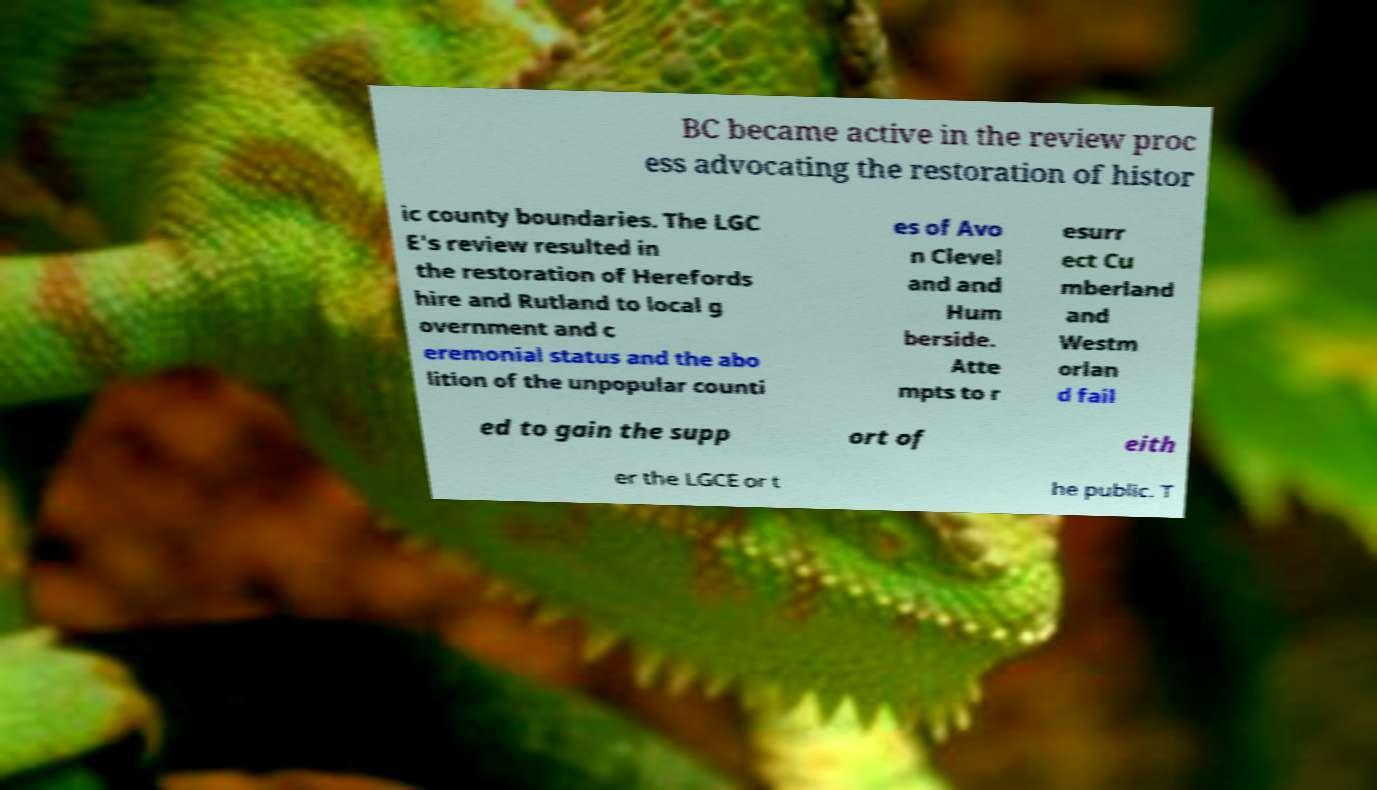Can you accurately transcribe the text from the provided image for me? BC became active in the review proc ess advocating the restoration of histor ic county boundaries. The LGC E's review resulted in the restoration of Herefords hire and Rutland to local g overnment and c eremonial status and the abo lition of the unpopular counti es of Avo n Clevel and and Hum berside. Atte mpts to r esurr ect Cu mberland and Westm orlan d fail ed to gain the supp ort of eith er the LGCE or t he public. T 